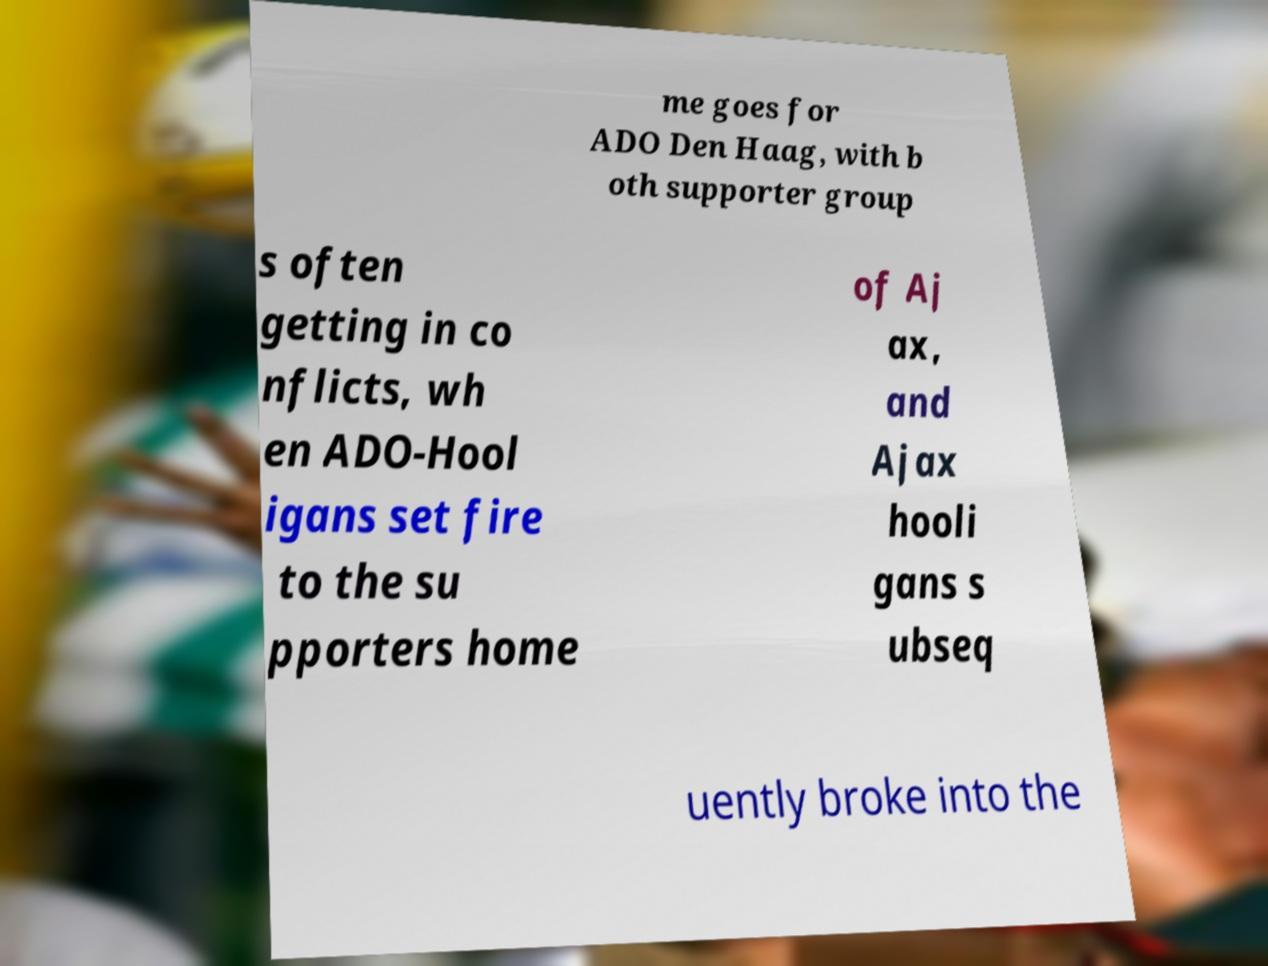Can you accurately transcribe the text from the provided image for me? me goes for ADO Den Haag, with b oth supporter group s often getting in co nflicts, wh en ADO-Hool igans set fire to the su pporters home of Aj ax, and Ajax hooli gans s ubseq uently broke into the 